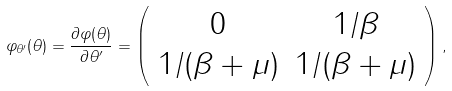<formula> <loc_0><loc_0><loc_500><loc_500>\varphi _ { \theta ^ { \prime } } ( \theta ) = \frac { \partial \varphi ( \theta ) } { \partial \theta ^ { \prime } } = \left ( \begin{array} { c c } 0 & 1 / \beta \\ 1 / ( \beta + \mu ) & 1 / ( \beta + \mu ) \end{array} \right ) ,</formula> 